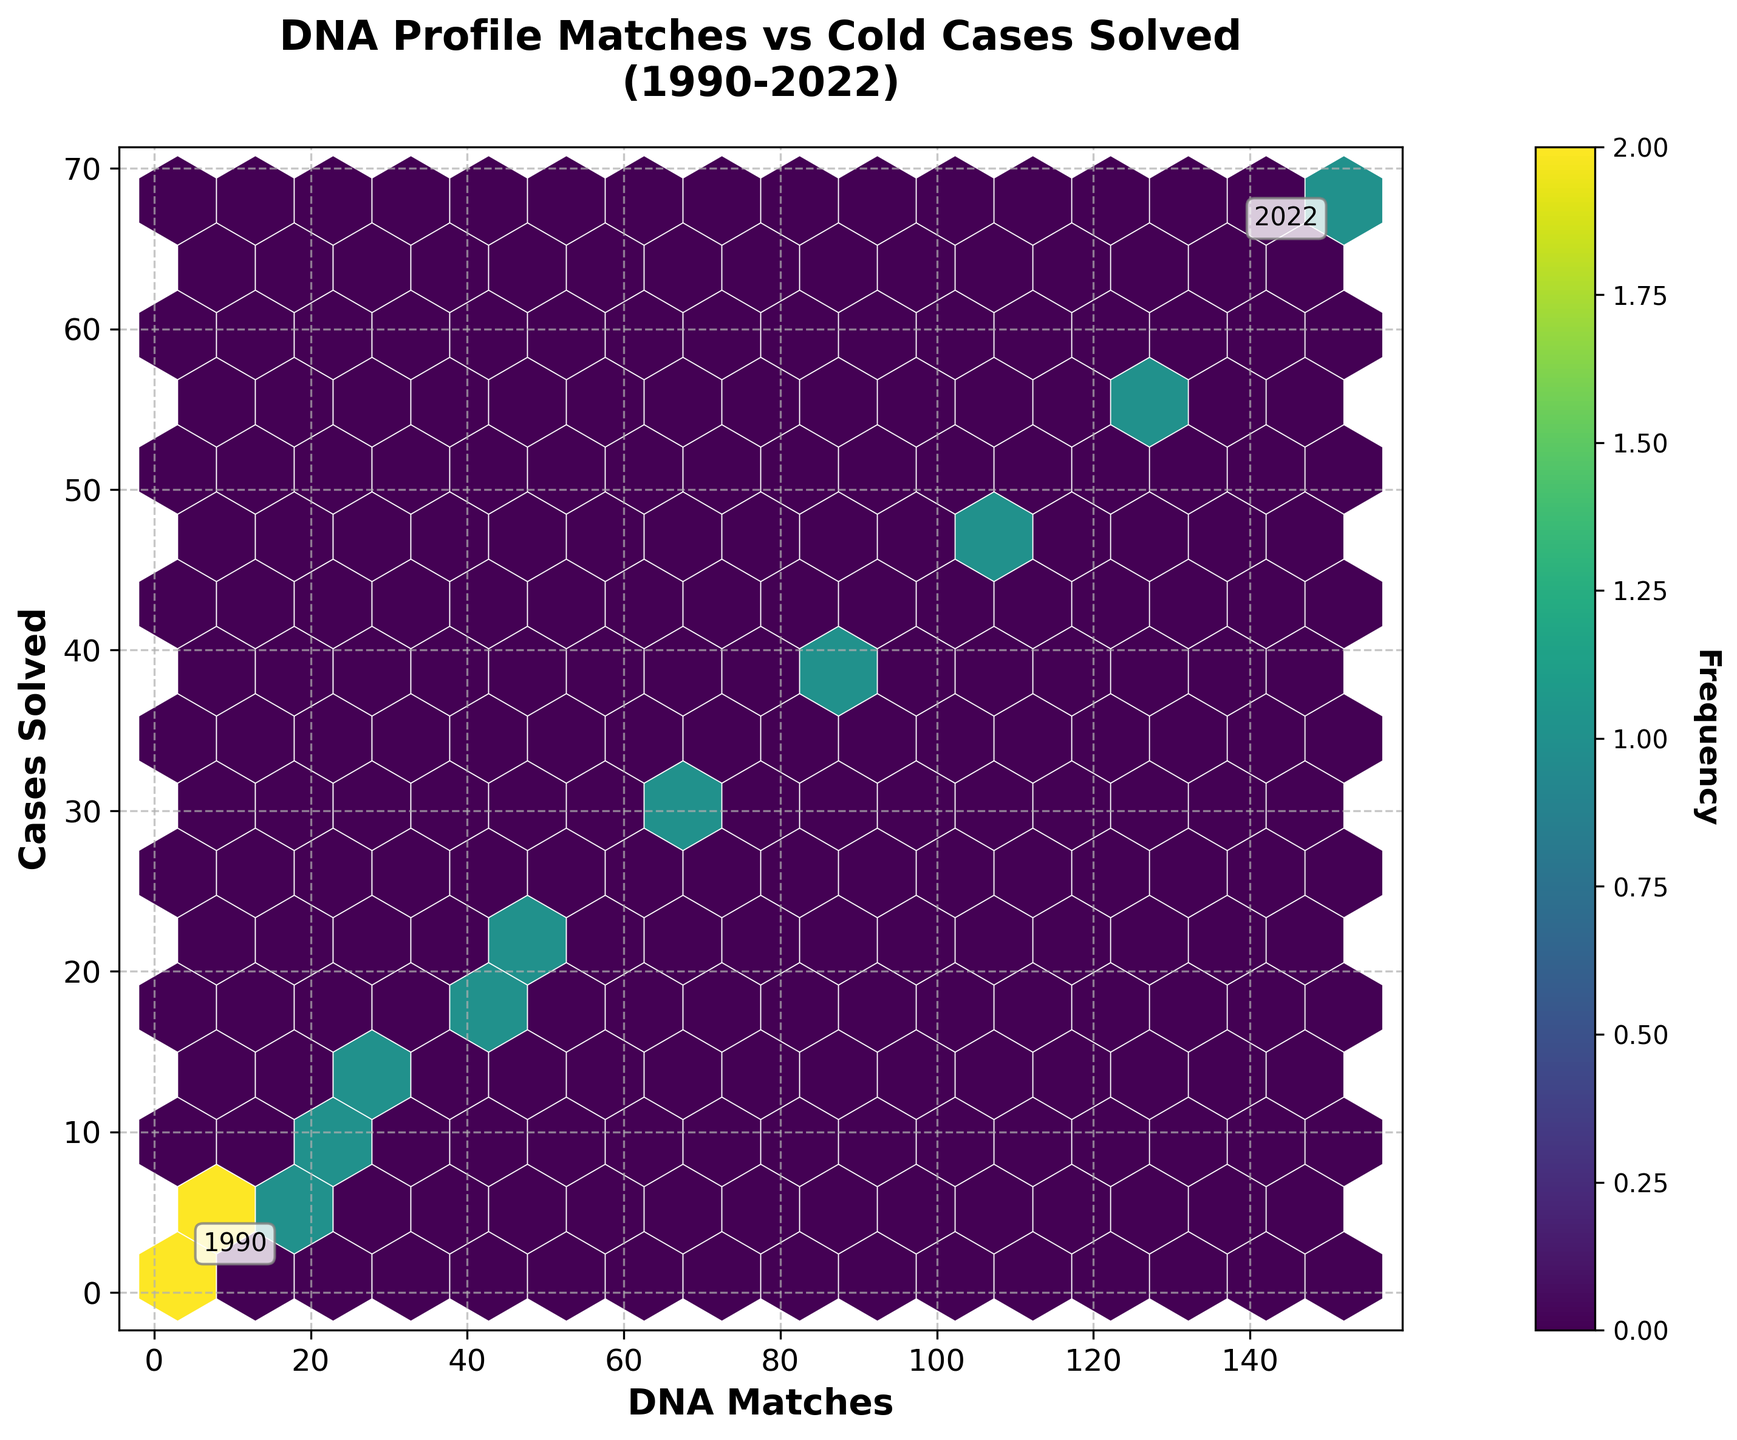How many hexagons are present in the plot? To determine the number of hexagons, you need to visually count the total number of hexbin cells displayed on the plot, considering the grid size of 15.
Answer: 15 What is the color used for indicating higher frequencies on the hexbin plot? The color used for higher frequencies is typically identified by the legend or color gradient displayed on the colorbar. In this case, darker shades or the most intense part of the 'viridis' colormap represent higher frequencies.
Answer: Dark Green/Black What is the relationship between DNA matches and cases solved as indicated by the plot’s title? The plot's title "DNA Profile Matches vs Cold Cases Solved (1990-2022)" suggests that there is a visual representation of the relationship between the number of DNA matches and the number of cold cases solved over the years.
Answer: The plot examines the correlation between DNA matches and cold cases solved Which annotation indicates the starting year of the data? The plot has text annotations indicating the years 1990 and 2022. The annotation '1990' marks the starting year.
Answer: 1990 Given the data points, which year has the highest number of DNA matches, and how many? According to the data, 2022 has the highest number of DNA matches with 152 matches.
Answer: 2022, 152 matches Which year shows the highest number of cases solved based on the annotations? The year annotated as 2022 shows the highest number of cases solved, corresponding to 68 cases.
Answer: 2022, 68 cases What does the colorbar label 'Frequency' indicate? The colorbar labeled 'Frequency' indicates how often the bins of the hexbin plot contain data points. The shades represent different frequencies of occurrences within the bins.
Answer: It indicates the number of data points within each bin What is the increment in the number of DNA matches from 2008 to 2010? According to the data, in 2008, there were 41 DNA matches, and in 2010, there were 52 DNA matches. The increment is 52 - 41 = 11.
Answer: 11 If the trend continues, estimate the number of cases solved if there are 200 DNA matches. The plot shows a roughly linear relationship between DNA matches and cases solved. Assuming the trend continues, with 152 DNA matches correlating to 68 cases solved, a rough linear extrapolation suggests (200 matches / 152 matches) * 68 cases ≈ 89.5.
Answer: Approximately 90 cases In which range of DNA matches do most high-frequency hexagons appear? To determine the range with the highest frequency, refer to the color intensity in the colorbar. The plot indicates that higher frequency hexagons primarily appear in the range of 52 to 128 DNA matches.
Answer: 52 to 128 DNA matches 